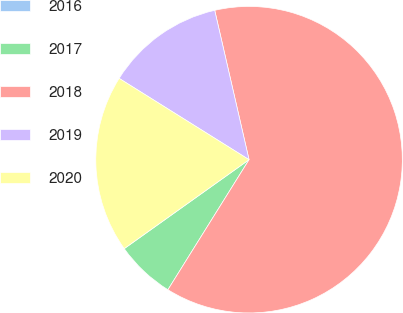<chart> <loc_0><loc_0><loc_500><loc_500><pie_chart><fcel>2016<fcel>2017<fcel>2018<fcel>2019<fcel>2020<nl><fcel>0.01%<fcel>6.26%<fcel>62.47%<fcel>12.5%<fcel>18.75%<nl></chart> 